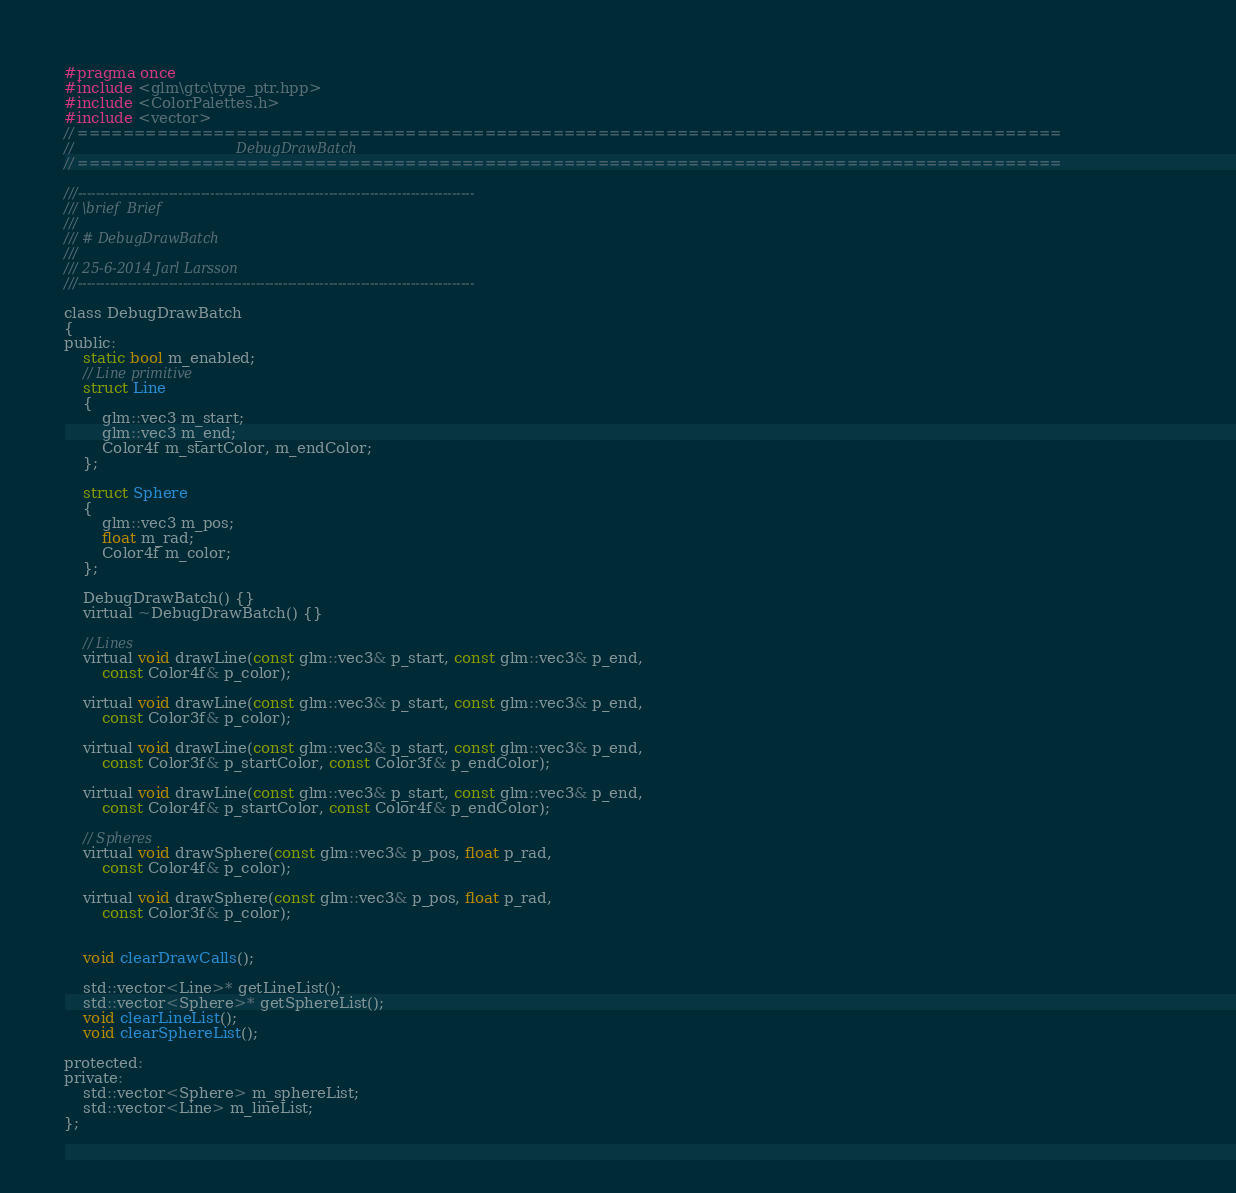Convert code to text. <code><loc_0><loc_0><loc_500><loc_500><_C_>#pragma once
#include <glm\gtc\type_ptr.hpp>
#include <ColorPalettes.h>
#include <vector>
// =======================================================================================
//                                      DebugDrawBatch
// =======================================================================================

///---------------------------------------------------------------------------------------
/// \brief	Brief
///        
/// # DebugDrawBatch
/// 
/// 25-6-2014 Jarl Larsson
///---------------------------------------------------------------------------------------

class DebugDrawBatch
{
public:
	static bool m_enabled;
	// Line primitive
	struct Line
	{
		glm::vec3 m_start;
		glm::vec3 m_end;
		Color4f m_startColor, m_endColor;
	};

	struct Sphere
	{
		glm::vec3 m_pos;
		float m_rad;
		Color4f m_color;
	};

	DebugDrawBatch() {}
	virtual ~DebugDrawBatch() {}

	// Lines
	virtual void drawLine(const glm::vec3& p_start, const glm::vec3& p_end,
		const Color4f& p_color);

	virtual void drawLine(const glm::vec3& p_start, const glm::vec3& p_end,
		const Color3f& p_color);

	virtual void drawLine(const glm::vec3& p_start, const glm::vec3& p_end,
		const Color3f& p_startColor, const Color3f& p_endColor);

	virtual void drawLine(const glm::vec3& p_start, const glm::vec3& p_end,
		const Color4f& p_startColor, const Color4f& p_endColor);

	// Spheres
	virtual void drawSphere(const glm::vec3& p_pos, float p_rad,
		const Color4f& p_color);

	virtual void drawSphere(const glm::vec3& p_pos, float p_rad,
		const Color3f& p_color);


	void clearDrawCalls();

	std::vector<Line>* getLineList();
	std::vector<Sphere>* getSphereList();
	void clearLineList();
	void clearSphereList();

protected:
private:
	std::vector<Sphere> m_sphereList;
	std::vector<Line> m_lineList;
};
</code> 